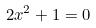Convert formula to latex. <formula><loc_0><loc_0><loc_500><loc_500>2 x ^ { 2 } + 1 = 0</formula> 